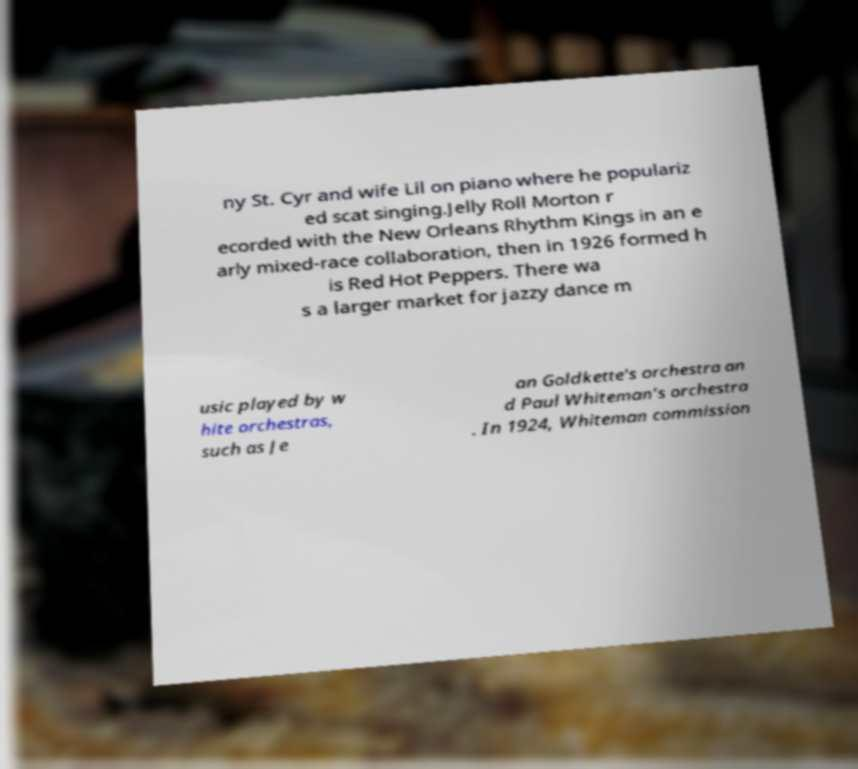There's text embedded in this image that I need extracted. Can you transcribe it verbatim? ny St. Cyr and wife Lil on piano where he populariz ed scat singing.Jelly Roll Morton r ecorded with the New Orleans Rhythm Kings in an e arly mixed-race collaboration, then in 1926 formed h is Red Hot Peppers. There wa s a larger market for jazzy dance m usic played by w hite orchestras, such as Je an Goldkette's orchestra an d Paul Whiteman's orchestra . In 1924, Whiteman commission 